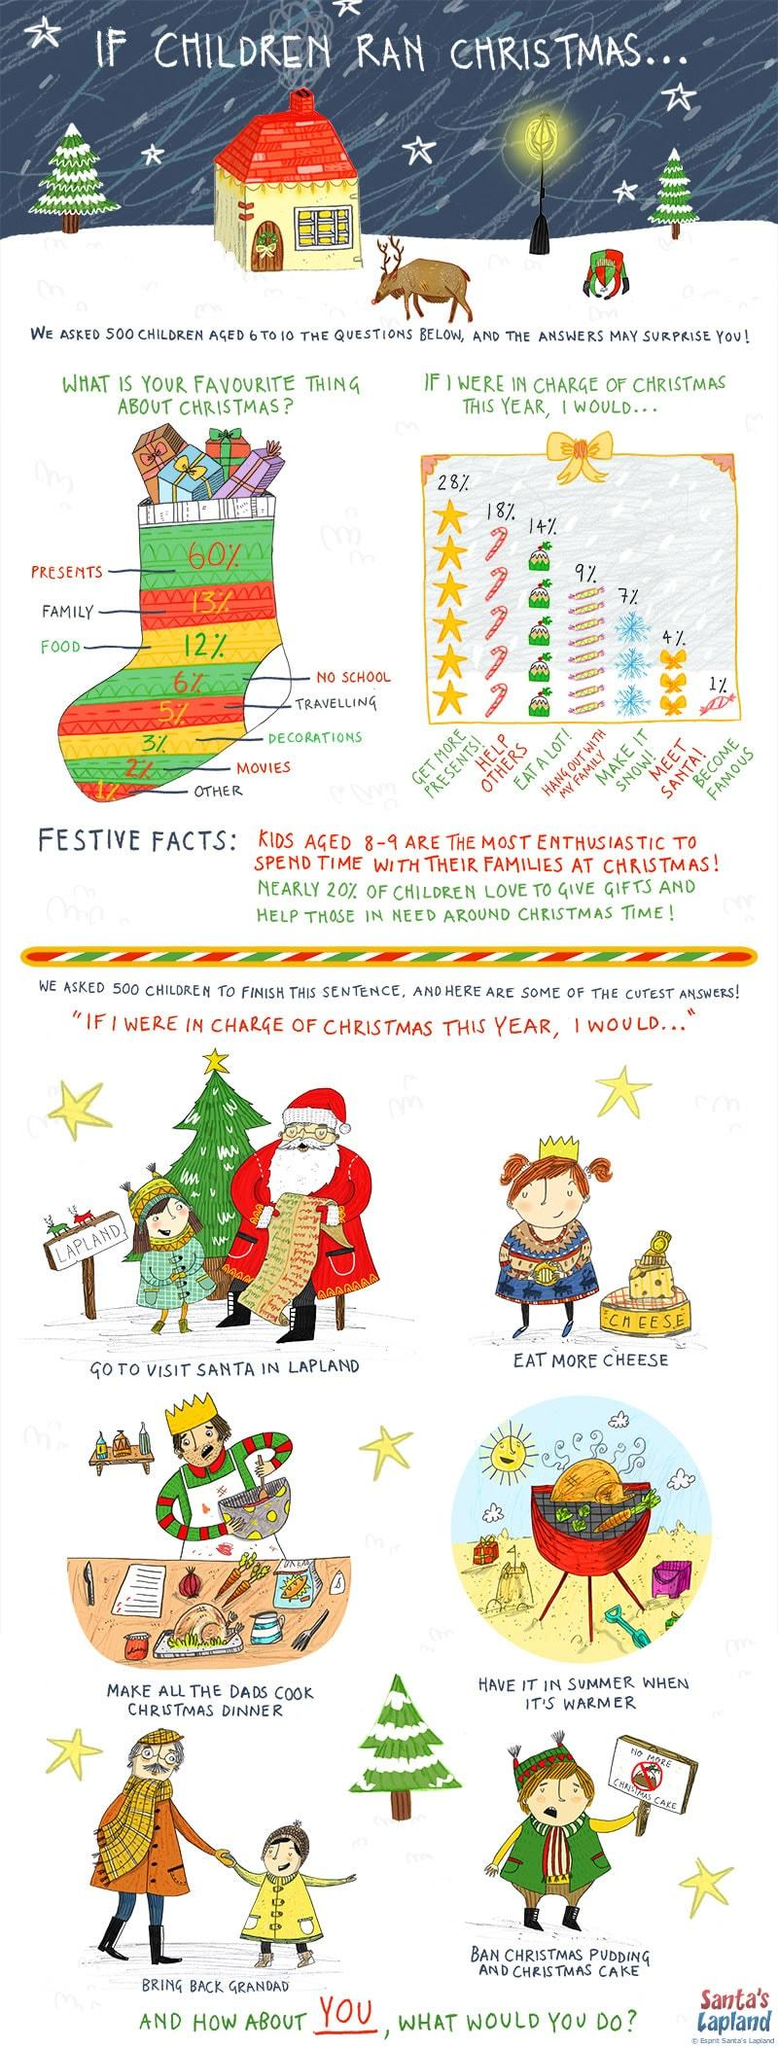Specify some key components in this picture. The top three things that children loved about Christmas were presents, family, and food. Nine percent of children expressed a desire to spend time with their families during the Christmas holiday season. The percentage difference between children who loved receiving presents and children who wanted to help others was found to be 10%. 